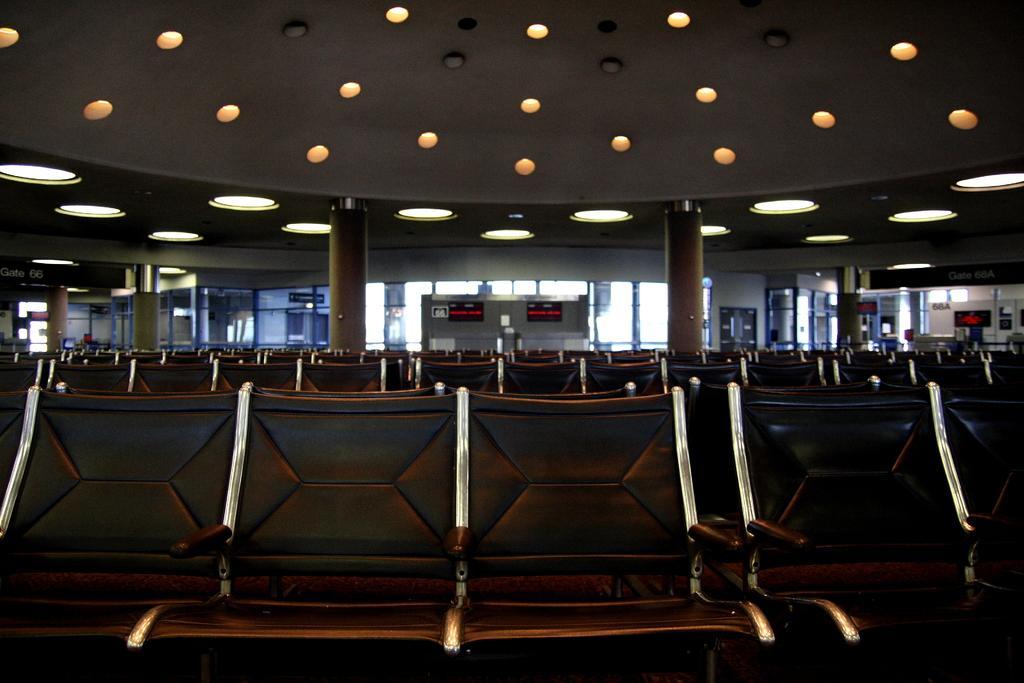What objects are in the image that are typically used for sitting? There is a group of empty chairs in the image. What architectural features can be seen in the image? Pillars, windows, and a wall are visible in the image. What type of surface is present in the image? Boards are present in the image. What part of the building's structure is visible in the image? A roof with ceiling lights is present in the image. What type of fish can be seen swimming near the wall in the image? There are no fish present in the image; it features a group of empty chairs, pillars, windows, boards, and a roof with ceiling lights. 